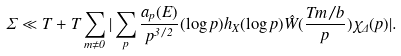Convert formula to latex. <formula><loc_0><loc_0><loc_500><loc_500>\Sigma \ll T + T \sum _ { m \not = 0 } | \sum _ { p } \frac { a _ { p } ( E ) } { p ^ { 3 / 2 } } ( \log p ) h _ { X } ( \log p ) \hat { W } ( \frac { T m / b } { p } ) \chi _ { \Delta } ( p ) | .</formula> 